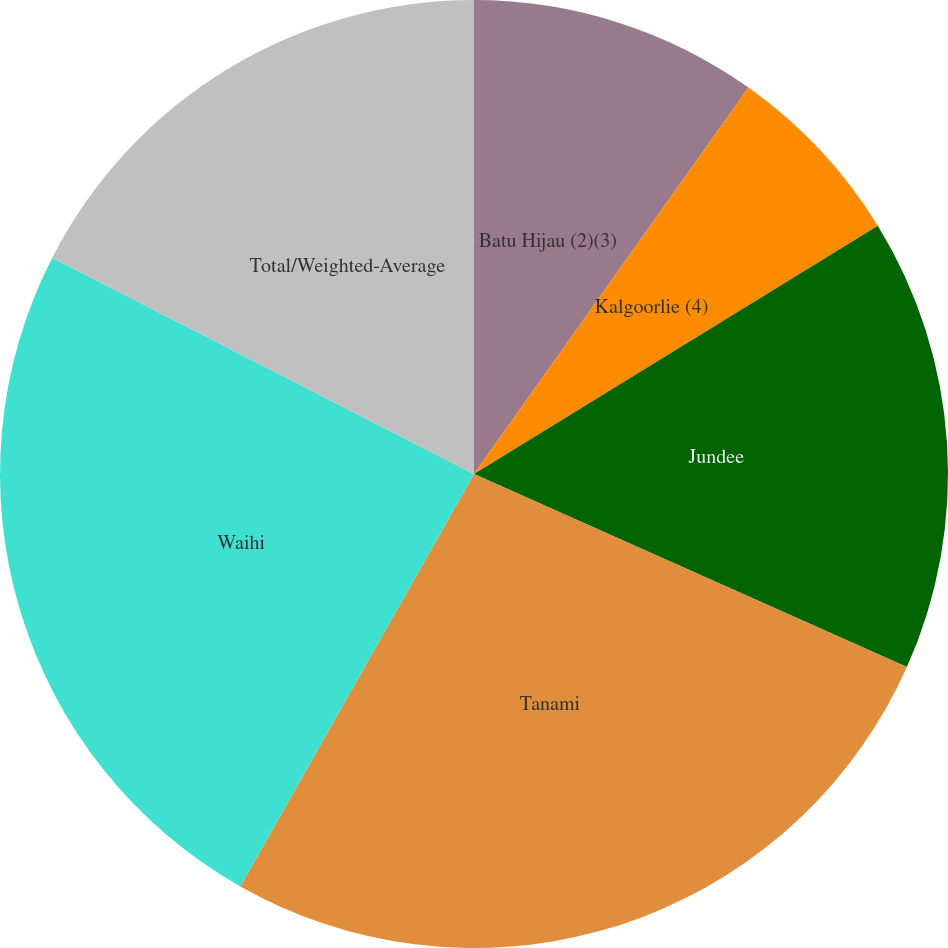Convert chart to OTSL. <chart><loc_0><loc_0><loc_500><loc_500><pie_chart><fcel>Batu Hijau (2)(3)<fcel>Kalgoorlie (4)<fcel>Jundee<fcel>Tanami<fcel>Waihi<fcel>Total/Weighted-Average<nl><fcel>9.83%<fcel>6.4%<fcel>15.45%<fcel>26.53%<fcel>24.34%<fcel>17.46%<nl></chart> 